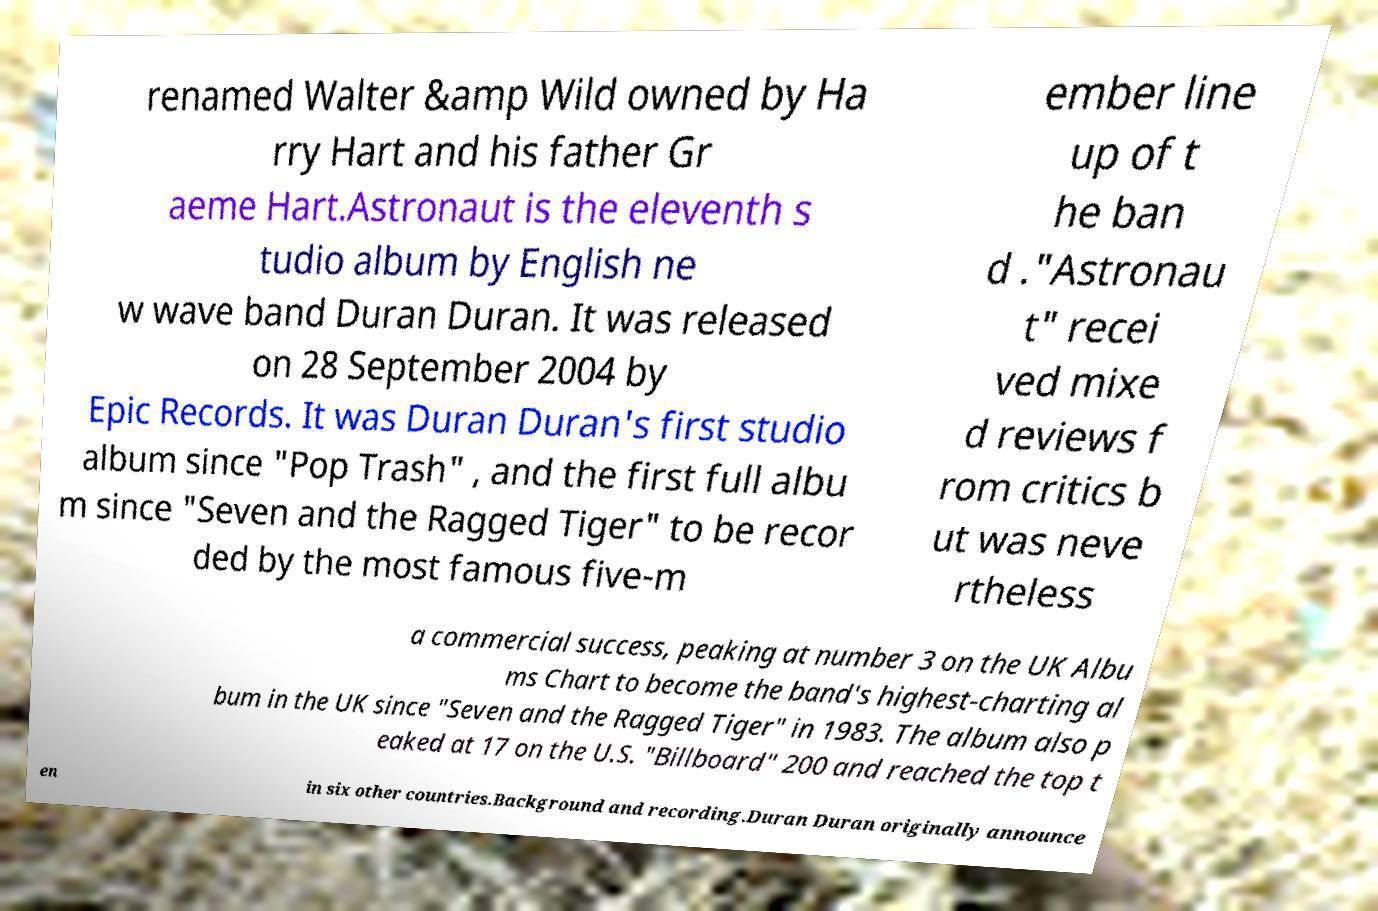Could you assist in decoding the text presented in this image and type it out clearly? renamed Walter &amp Wild owned by Ha rry Hart and his father Gr aeme Hart.Astronaut is the eleventh s tudio album by English ne w wave band Duran Duran. It was released on 28 September 2004 by Epic Records. It was Duran Duran's first studio album since "Pop Trash" , and the first full albu m since "Seven and the Ragged Tiger" to be recor ded by the most famous five-m ember line up of t he ban d ."Astronau t" recei ved mixe d reviews f rom critics b ut was neve rtheless a commercial success, peaking at number 3 on the UK Albu ms Chart to become the band's highest-charting al bum in the UK since "Seven and the Ragged Tiger" in 1983. The album also p eaked at 17 on the U.S. "Billboard" 200 and reached the top t en in six other countries.Background and recording.Duran Duran originally announce 